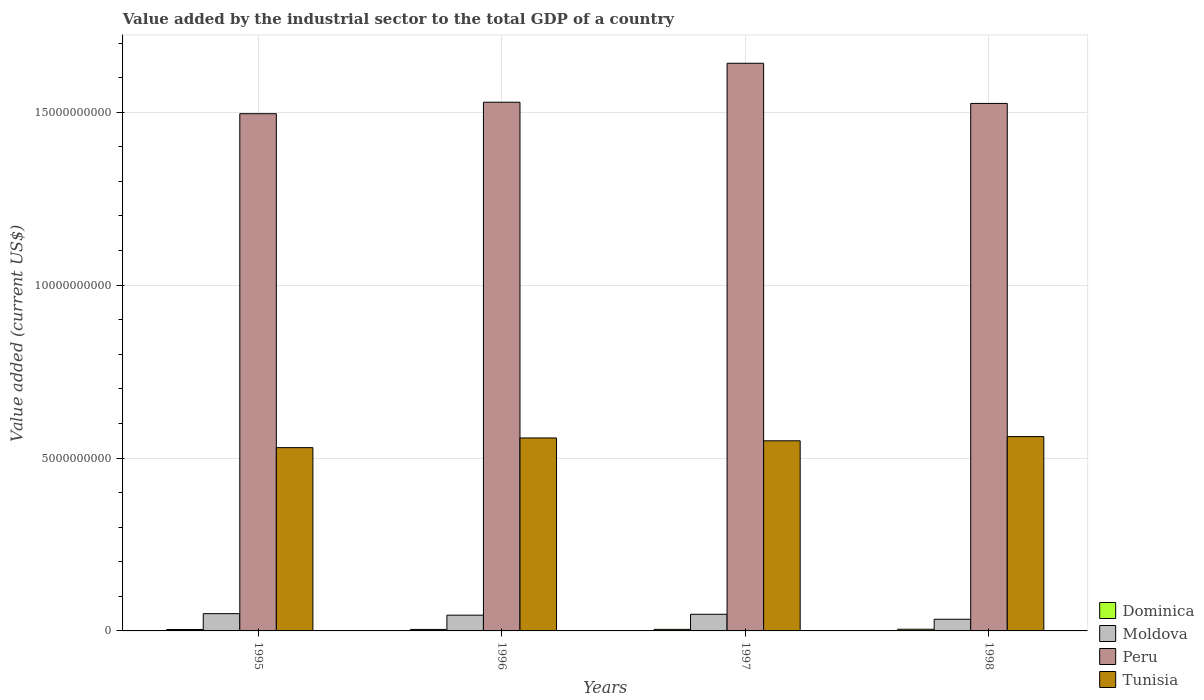Are the number of bars per tick equal to the number of legend labels?
Offer a very short reply. Yes. Are the number of bars on each tick of the X-axis equal?
Offer a terse response. Yes. How many bars are there on the 1st tick from the left?
Your response must be concise. 4. What is the value added by the industrial sector to the total GDP in Tunisia in 1995?
Your answer should be very brief. 5.30e+09. Across all years, what is the maximum value added by the industrial sector to the total GDP in Moldova?
Your answer should be compact. 5.00e+08. Across all years, what is the minimum value added by the industrial sector to the total GDP in Dominica?
Give a very brief answer. 4.07e+07. In which year was the value added by the industrial sector to the total GDP in Tunisia maximum?
Give a very brief answer. 1998. What is the total value added by the industrial sector to the total GDP in Peru in the graph?
Give a very brief answer. 6.19e+1. What is the difference between the value added by the industrial sector to the total GDP in Peru in 1995 and that in 1997?
Your answer should be compact. -1.46e+09. What is the difference between the value added by the industrial sector to the total GDP in Dominica in 1998 and the value added by the industrial sector to the total GDP in Peru in 1995?
Offer a terse response. -1.49e+1. What is the average value added by the industrial sector to the total GDP in Moldova per year?
Offer a terse response. 4.44e+08. In the year 1997, what is the difference between the value added by the industrial sector to the total GDP in Dominica and value added by the industrial sector to the total GDP in Tunisia?
Provide a short and direct response. -5.45e+09. What is the ratio of the value added by the industrial sector to the total GDP in Moldova in 1996 to that in 1997?
Provide a succinct answer. 0.95. Is the value added by the industrial sector to the total GDP in Moldova in 1996 less than that in 1998?
Make the answer very short. No. What is the difference between the highest and the second highest value added by the industrial sector to the total GDP in Moldova?
Offer a terse response. 1.80e+07. What is the difference between the highest and the lowest value added by the industrial sector to the total GDP in Tunisia?
Offer a very short reply. 3.20e+08. In how many years, is the value added by the industrial sector to the total GDP in Tunisia greater than the average value added by the industrial sector to the total GDP in Tunisia taken over all years?
Your response must be concise. 2. What does the 1st bar from the right in 1995 represents?
Ensure brevity in your answer.  Tunisia. Is it the case that in every year, the sum of the value added by the industrial sector to the total GDP in Moldova and value added by the industrial sector to the total GDP in Dominica is greater than the value added by the industrial sector to the total GDP in Peru?
Provide a short and direct response. No. How many bars are there?
Your answer should be compact. 16. How many years are there in the graph?
Your response must be concise. 4. Does the graph contain any zero values?
Your response must be concise. No. Where does the legend appear in the graph?
Your answer should be very brief. Bottom right. What is the title of the graph?
Your response must be concise. Value added by the industrial sector to the total GDP of a country. Does "Botswana" appear as one of the legend labels in the graph?
Keep it short and to the point. No. What is the label or title of the Y-axis?
Provide a short and direct response. Value added (current US$). What is the Value added (current US$) of Dominica in 1995?
Provide a succinct answer. 4.07e+07. What is the Value added (current US$) of Moldova in 1995?
Ensure brevity in your answer.  5.00e+08. What is the Value added (current US$) of Peru in 1995?
Offer a terse response. 1.50e+1. What is the Value added (current US$) of Tunisia in 1995?
Your answer should be very brief. 5.30e+09. What is the Value added (current US$) of Dominica in 1996?
Provide a short and direct response. 4.31e+07. What is the Value added (current US$) of Moldova in 1996?
Provide a succinct answer. 4.56e+08. What is the Value added (current US$) of Peru in 1996?
Offer a very short reply. 1.53e+1. What is the Value added (current US$) of Tunisia in 1996?
Offer a very short reply. 5.58e+09. What is the Value added (current US$) of Dominica in 1997?
Keep it short and to the point. 4.49e+07. What is the Value added (current US$) of Moldova in 1997?
Offer a terse response. 4.82e+08. What is the Value added (current US$) of Peru in 1997?
Give a very brief answer. 1.64e+1. What is the Value added (current US$) in Tunisia in 1997?
Your response must be concise. 5.50e+09. What is the Value added (current US$) in Dominica in 1998?
Make the answer very short. 4.85e+07. What is the Value added (current US$) in Moldova in 1998?
Provide a short and direct response. 3.37e+08. What is the Value added (current US$) of Peru in 1998?
Your answer should be compact. 1.53e+1. What is the Value added (current US$) in Tunisia in 1998?
Keep it short and to the point. 5.62e+09. Across all years, what is the maximum Value added (current US$) in Dominica?
Keep it short and to the point. 4.85e+07. Across all years, what is the maximum Value added (current US$) in Moldova?
Make the answer very short. 5.00e+08. Across all years, what is the maximum Value added (current US$) of Peru?
Offer a terse response. 1.64e+1. Across all years, what is the maximum Value added (current US$) in Tunisia?
Offer a very short reply. 5.62e+09. Across all years, what is the minimum Value added (current US$) in Dominica?
Provide a short and direct response. 4.07e+07. Across all years, what is the minimum Value added (current US$) in Moldova?
Offer a very short reply. 3.37e+08. Across all years, what is the minimum Value added (current US$) of Peru?
Your answer should be compact. 1.50e+1. Across all years, what is the minimum Value added (current US$) of Tunisia?
Offer a terse response. 5.30e+09. What is the total Value added (current US$) in Dominica in the graph?
Provide a succinct answer. 1.77e+08. What is the total Value added (current US$) of Moldova in the graph?
Provide a short and direct response. 1.77e+09. What is the total Value added (current US$) of Peru in the graph?
Your answer should be very brief. 6.19e+1. What is the total Value added (current US$) of Tunisia in the graph?
Offer a very short reply. 2.20e+1. What is the difference between the Value added (current US$) in Dominica in 1995 and that in 1996?
Ensure brevity in your answer.  -2.38e+06. What is the difference between the Value added (current US$) of Moldova in 1995 and that in 1996?
Provide a short and direct response. 4.39e+07. What is the difference between the Value added (current US$) of Peru in 1995 and that in 1996?
Your answer should be compact. -3.32e+08. What is the difference between the Value added (current US$) in Tunisia in 1995 and that in 1996?
Give a very brief answer. -2.80e+08. What is the difference between the Value added (current US$) of Dominica in 1995 and that in 1997?
Offer a terse response. -4.19e+06. What is the difference between the Value added (current US$) in Moldova in 1995 and that in 1997?
Offer a very short reply. 1.80e+07. What is the difference between the Value added (current US$) in Peru in 1995 and that in 1997?
Make the answer very short. -1.46e+09. What is the difference between the Value added (current US$) of Tunisia in 1995 and that in 1997?
Your answer should be compact. -1.98e+08. What is the difference between the Value added (current US$) of Dominica in 1995 and that in 1998?
Provide a succinct answer. -7.78e+06. What is the difference between the Value added (current US$) of Moldova in 1995 and that in 1998?
Keep it short and to the point. 1.62e+08. What is the difference between the Value added (current US$) in Peru in 1995 and that in 1998?
Make the answer very short. -2.97e+08. What is the difference between the Value added (current US$) in Tunisia in 1995 and that in 1998?
Give a very brief answer. -3.20e+08. What is the difference between the Value added (current US$) in Dominica in 1996 and that in 1997?
Give a very brief answer. -1.81e+06. What is the difference between the Value added (current US$) in Moldova in 1996 and that in 1997?
Your answer should be compact. -2.59e+07. What is the difference between the Value added (current US$) in Peru in 1996 and that in 1997?
Offer a terse response. -1.13e+09. What is the difference between the Value added (current US$) in Tunisia in 1996 and that in 1997?
Keep it short and to the point. 8.22e+07. What is the difference between the Value added (current US$) in Dominica in 1996 and that in 1998?
Provide a succinct answer. -5.40e+06. What is the difference between the Value added (current US$) of Moldova in 1996 and that in 1998?
Provide a short and direct response. 1.19e+08. What is the difference between the Value added (current US$) in Peru in 1996 and that in 1998?
Your answer should be compact. 3.49e+07. What is the difference between the Value added (current US$) of Tunisia in 1996 and that in 1998?
Ensure brevity in your answer.  -3.98e+07. What is the difference between the Value added (current US$) of Dominica in 1997 and that in 1998?
Your answer should be very brief. -3.59e+06. What is the difference between the Value added (current US$) of Moldova in 1997 and that in 1998?
Give a very brief answer. 1.44e+08. What is the difference between the Value added (current US$) of Peru in 1997 and that in 1998?
Give a very brief answer. 1.16e+09. What is the difference between the Value added (current US$) in Tunisia in 1997 and that in 1998?
Keep it short and to the point. -1.22e+08. What is the difference between the Value added (current US$) of Dominica in 1995 and the Value added (current US$) of Moldova in 1996?
Provide a succinct answer. -4.15e+08. What is the difference between the Value added (current US$) in Dominica in 1995 and the Value added (current US$) in Peru in 1996?
Provide a short and direct response. -1.52e+1. What is the difference between the Value added (current US$) of Dominica in 1995 and the Value added (current US$) of Tunisia in 1996?
Your answer should be compact. -5.54e+09. What is the difference between the Value added (current US$) of Moldova in 1995 and the Value added (current US$) of Peru in 1996?
Offer a very short reply. -1.48e+1. What is the difference between the Value added (current US$) in Moldova in 1995 and the Value added (current US$) in Tunisia in 1996?
Offer a terse response. -5.08e+09. What is the difference between the Value added (current US$) of Peru in 1995 and the Value added (current US$) of Tunisia in 1996?
Offer a terse response. 9.38e+09. What is the difference between the Value added (current US$) of Dominica in 1995 and the Value added (current US$) of Moldova in 1997?
Your answer should be compact. -4.41e+08. What is the difference between the Value added (current US$) in Dominica in 1995 and the Value added (current US$) in Peru in 1997?
Provide a succinct answer. -1.64e+1. What is the difference between the Value added (current US$) of Dominica in 1995 and the Value added (current US$) of Tunisia in 1997?
Make the answer very short. -5.46e+09. What is the difference between the Value added (current US$) of Moldova in 1995 and the Value added (current US$) of Peru in 1997?
Provide a succinct answer. -1.59e+1. What is the difference between the Value added (current US$) of Moldova in 1995 and the Value added (current US$) of Tunisia in 1997?
Make the answer very short. -5.00e+09. What is the difference between the Value added (current US$) of Peru in 1995 and the Value added (current US$) of Tunisia in 1997?
Provide a succinct answer. 9.46e+09. What is the difference between the Value added (current US$) of Dominica in 1995 and the Value added (current US$) of Moldova in 1998?
Keep it short and to the point. -2.96e+08. What is the difference between the Value added (current US$) of Dominica in 1995 and the Value added (current US$) of Peru in 1998?
Provide a succinct answer. -1.52e+1. What is the difference between the Value added (current US$) in Dominica in 1995 and the Value added (current US$) in Tunisia in 1998?
Your answer should be compact. -5.58e+09. What is the difference between the Value added (current US$) in Moldova in 1995 and the Value added (current US$) in Peru in 1998?
Offer a very short reply. -1.48e+1. What is the difference between the Value added (current US$) of Moldova in 1995 and the Value added (current US$) of Tunisia in 1998?
Offer a very short reply. -5.12e+09. What is the difference between the Value added (current US$) in Peru in 1995 and the Value added (current US$) in Tunisia in 1998?
Provide a succinct answer. 9.34e+09. What is the difference between the Value added (current US$) of Dominica in 1996 and the Value added (current US$) of Moldova in 1997?
Ensure brevity in your answer.  -4.39e+08. What is the difference between the Value added (current US$) of Dominica in 1996 and the Value added (current US$) of Peru in 1997?
Your answer should be compact. -1.64e+1. What is the difference between the Value added (current US$) of Dominica in 1996 and the Value added (current US$) of Tunisia in 1997?
Your answer should be very brief. -5.45e+09. What is the difference between the Value added (current US$) of Moldova in 1996 and the Value added (current US$) of Peru in 1997?
Give a very brief answer. -1.60e+1. What is the difference between the Value added (current US$) of Moldova in 1996 and the Value added (current US$) of Tunisia in 1997?
Make the answer very short. -5.04e+09. What is the difference between the Value added (current US$) of Peru in 1996 and the Value added (current US$) of Tunisia in 1997?
Offer a terse response. 9.79e+09. What is the difference between the Value added (current US$) in Dominica in 1996 and the Value added (current US$) in Moldova in 1998?
Provide a succinct answer. -2.94e+08. What is the difference between the Value added (current US$) of Dominica in 1996 and the Value added (current US$) of Peru in 1998?
Make the answer very short. -1.52e+1. What is the difference between the Value added (current US$) in Dominica in 1996 and the Value added (current US$) in Tunisia in 1998?
Make the answer very short. -5.58e+09. What is the difference between the Value added (current US$) of Moldova in 1996 and the Value added (current US$) of Peru in 1998?
Make the answer very short. -1.48e+1. What is the difference between the Value added (current US$) of Moldova in 1996 and the Value added (current US$) of Tunisia in 1998?
Give a very brief answer. -5.16e+09. What is the difference between the Value added (current US$) of Peru in 1996 and the Value added (current US$) of Tunisia in 1998?
Give a very brief answer. 9.67e+09. What is the difference between the Value added (current US$) of Dominica in 1997 and the Value added (current US$) of Moldova in 1998?
Offer a terse response. -2.92e+08. What is the difference between the Value added (current US$) of Dominica in 1997 and the Value added (current US$) of Peru in 1998?
Provide a succinct answer. -1.52e+1. What is the difference between the Value added (current US$) in Dominica in 1997 and the Value added (current US$) in Tunisia in 1998?
Keep it short and to the point. -5.58e+09. What is the difference between the Value added (current US$) in Moldova in 1997 and the Value added (current US$) in Peru in 1998?
Offer a terse response. -1.48e+1. What is the difference between the Value added (current US$) of Moldova in 1997 and the Value added (current US$) of Tunisia in 1998?
Give a very brief answer. -5.14e+09. What is the difference between the Value added (current US$) in Peru in 1997 and the Value added (current US$) in Tunisia in 1998?
Your answer should be very brief. 1.08e+1. What is the average Value added (current US$) of Dominica per year?
Keep it short and to the point. 4.43e+07. What is the average Value added (current US$) in Moldova per year?
Your response must be concise. 4.44e+08. What is the average Value added (current US$) of Peru per year?
Provide a succinct answer. 1.55e+1. What is the average Value added (current US$) of Tunisia per year?
Give a very brief answer. 5.50e+09. In the year 1995, what is the difference between the Value added (current US$) in Dominica and Value added (current US$) in Moldova?
Provide a succinct answer. -4.59e+08. In the year 1995, what is the difference between the Value added (current US$) of Dominica and Value added (current US$) of Peru?
Ensure brevity in your answer.  -1.49e+1. In the year 1995, what is the difference between the Value added (current US$) in Dominica and Value added (current US$) in Tunisia?
Provide a short and direct response. -5.26e+09. In the year 1995, what is the difference between the Value added (current US$) in Moldova and Value added (current US$) in Peru?
Give a very brief answer. -1.45e+1. In the year 1995, what is the difference between the Value added (current US$) of Moldova and Value added (current US$) of Tunisia?
Your response must be concise. -4.80e+09. In the year 1995, what is the difference between the Value added (current US$) of Peru and Value added (current US$) of Tunisia?
Offer a very short reply. 9.66e+09. In the year 1996, what is the difference between the Value added (current US$) in Dominica and Value added (current US$) in Moldova?
Keep it short and to the point. -4.13e+08. In the year 1996, what is the difference between the Value added (current US$) in Dominica and Value added (current US$) in Peru?
Keep it short and to the point. -1.52e+1. In the year 1996, what is the difference between the Value added (current US$) of Dominica and Value added (current US$) of Tunisia?
Keep it short and to the point. -5.54e+09. In the year 1996, what is the difference between the Value added (current US$) in Moldova and Value added (current US$) in Peru?
Your answer should be compact. -1.48e+1. In the year 1996, what is the difference between the Value added (current US$) of Moldova and Value added (current US$) of Tunisia?
Your answer should be very brief. -5.12e+09. In the year 1996, what is the difference between the Value added (current US$) in Peru and Value added (current US$) in Tunisia?
Make the answer very short. 9.71e+09. In the year 1997, what is the difference between the Value added (current US$) in Dominica and Value added (current US$) in Moldova?
Make the answer very short. -4.37e+08. In the year 1997, what is the difference between the Value added (current US$) in Dominica and Value added (current US$) in Peru?
Ensure brevity in your answer.  -1.64e+1. In the year 1997, what is the difference between the Value added (current US$) of Dominica and Value added (current US$) of Tunisia?
Provide a succinct answer. -5.45e+09. In the year 1997, what is the difference between the Value added (current US$) of Moldova and Value added (current US$) of Peru?
Your answer should be very brief. -1.59e+1. In the year 1997, what is the difference between the Value added (current US$) in Moldova and Value added (current US$) in Tunisia?
Provide a succinct answer. -5.02e+09. In the year 1997, what is the difference between the Value added (current US$) in Peru and Value added (current US$) in Tunisia?
Your answer should be compact. 1.09e+1. In the year 1998, what is the difference between the Value added (current US$) in Dominica and Value added (current US$) in Moldova?
Your response must be concise. -2.89e+08. In the year 1998, what is the difference between the Value added (current US$) of Dominica and Value added (current US$) of Peru?
Offer a very short reply. -1.52e+1. In the year 1998, what is the difference between the Value added (current US$) of Dominica and Value added (current US$) of Tunisia?
Your answer should be compact. -5.57e+09. In the year 1998, what is the difference between the Value added (current US$) in Moldova and Value added (current US$) in Peru?
Give a very brief answer. -1.49e+1. In the year 1998, what is the difference between the Value added (current US$) in Moldova and Value added (current US$) in Tunisia?
Offer a very short reply. -5.28e+09. In the year 1998, what is the difference between the Value added (current US$) in Peru and Value added (current US$) in Tunisia?
Offer a very short reply. 9.63e+09. What is the ratio of the Value added (current US$) in Dominica in 1995 to that in 1996?
Keep it short and to the point. 0.94. What is the ratio of the Value added (current US$) in Moldova in 1995 to that in 1996?
Provide a short and direct response. 1.1. What is the ratio of the Value added (current US$) of Peru in 1995 to that in 1996?
Provide a succinct answer. 0.98. What is the ratio of the Value added (current US$) in Tunisia in 1995 to that in 1996?
Keep it short and to the point. 0.95. What is the ratio of the Value added (current US$) of Dominica in 1995 to that in 1997?
Ensure brevity in your answer.  0.91. What is the ratio of the Value added (current US$) of Moldova in 1995 to that in 1997?
Your response must be concise. 1.04. What is the ratio of the Value added (current US$) in Peru in 1995 to that in 1997?
Make the answer very short. 0.91. What is the ratio of the Value added (current US$) in Dominica in 1995 to that in 1998?
Provide a short and direct response. 0.84. What is the ratio of the Value added (current US$) of Moldova in 1995 to that in 1998?
Give a very brief answer. 1.48. What is the ratio of the Value added (current US$) in Peru in 1995 to that in 1998?
Your response must be concise. 0.98. What is the ratio of the Value added (current US$) in Tunisia in 1995 to that in 1998?
Offer a very short reply. 0.94. What is the ratio of the Value added (current US$) in Dominica in 1996 to that in 1997?
Offer a very short reply. 0.96. What is the ratio of the Value added (current US$) in Moldova in 1996 to that in 1997?
Keep it short and to the point. 0.95. What is the ratio of the Value added (current US$) in Peru in 1996 to that in 1997?
Provide a short and direct response. 0.93. What is the ratio of the Value added (current US$) of Tunisia in 1996 to that in 1997?
Provide a short and direct response. 1.01. What is the ratio of the Value added (current US$) in Dominica in 1996 to that in 1998?
Your response must be concise. 0.89. What is the ratio of the Value added (current US$) in Moldova in 1996 to that in 1998?
Your answer should be compact. 1.35. What is the ratio of the Value added (current US$) of Dominica in 1997 to that in 1998?
Offer a very short reply. 0.93. What is the ratio of the Value added (current US$) in Moldova in 1997 to that in 1998?
Your answer should be very brief. 1.43. What is the ratio of the Value added (current US$) in Peru in 1997 to that in 1998?
Provide a succinct answer. 1.08. What is the ratio of the Value added (current US$) of Tunisia in 1997 to that in 1998?
Your response must be concise. 0.98. What is the difference between the highest and the second highest Value added (current US$) of Dominica?
Offer a terse response. 3.59e+06. What is the difference between the highest and the second highest Value added (current US$) of Moldova?
Ensure brevity in your answer.  1.80e+07. What is the difference between the highest and the second highest Value added (current US$) of Peru?
Give a very brief answer. 1.13e+09. What is the difference between the highest and the second highest Value added (current US$) in Tunisia?
Provide a succinct answer. 3.98e+07. What is the difference between the highest and the lowest Value added (current US$) in Dominica?
Your response must be concise. 7.78e+06. What is the difference between the highest and the lowest Value added (current US$) in Moldova?
Your answer should be very brief. 1.62e+08. What is the difference between the highest and the lowest Value added (current US$) of Peru?
Keep it short and to the point. 1.46e+09. What is the difference between the highest and the lowest Value added (current US$) of Tunisia?
Keep it short and to the point. 3.20e+08. 